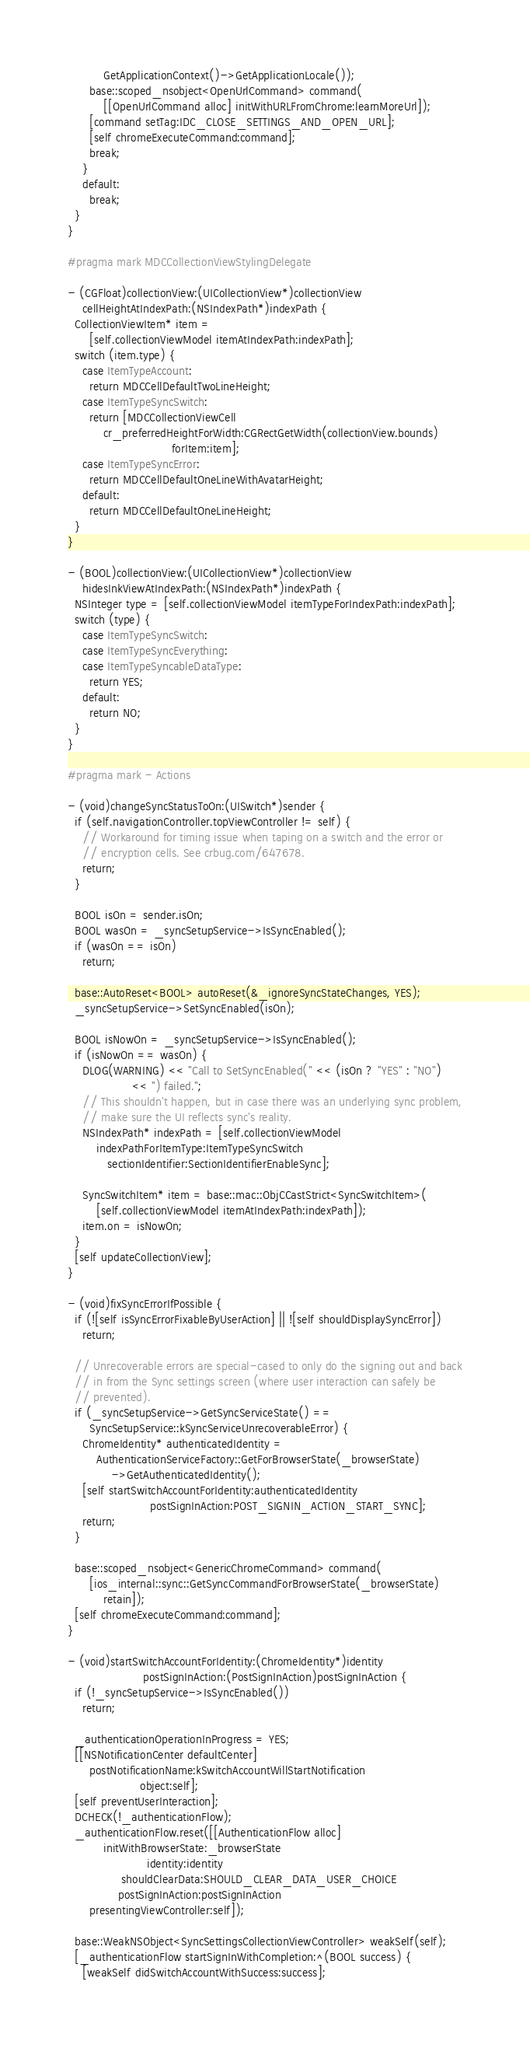Convert code to text. <code><loc_0><loc_0><loc_500><loc_500><_ObjectiveC_>          GetApplicationContext()->GetApplicationLocale());
      base::scoped_nsobject<OpenUrlCommand> command(
          [[OpenUrlCommand alloc] initWithURLFromChrome:learnMoreUrl]);
      [command setTag:IDC_CLOSE_SETTINGS_AND_OPEN_URL];
      [self chromeExecuteCommand:command];
      break;
    }
    default:
      break;
  }
}

#pragma mark MDCCollectionViewStylingDelegate

- (CGFloat)collectionView:(UICollectionView*)collectionView
    cellHeightAtIndexPath:(NSIndexPath*)indexPath {
  CollectionViewItem* item =
      [self.collectionViewModel itemAtIndexPath:indexPath];
  switch (item.type) {
    case ItemTypeAccount:
      return MDCCellDefaultTwoLineHeight;
    case ItemTypeSyncSwitch:
      return [MDCCollectionViewCell
          cr_preferredHeightForWidth:CGRectGetWidth(collectionView.bounds)
                             forItem:item];
    case ItemTypeSyncError:
      return MDCCellDefaultOneLineWithAvatarHeight;
    default:
      return MDCCellDefaultOneLineHeight;
  }
}

- (BOOL)collectionView:(UICollectionView*)collectionView
    hidesInkViewAtIndexPath:(NSIndexPath*)indexPath {
  NSInteger type = [self.collectionViewModel itemTypeForIndexPath:indexPath];
  switch (type) {
    case ItemTypeSyncSwitch:
    case ItemTypeSyncEverything:
    case ItemTypeSyncableDataType:
      return YES;
    default:
      return NO;
  }
}

#pragma mark - Actions

- (void)changeSyncStatusToOn:(UISwitch*)sender {
  if (self.navigationController.topViewController != self) {
    // Workaround for timing issue when taping on a switch and the error or
    // encryption cells. See crbug.com/647678.
    return;
  }

  BOOL isOn = sender.isOn;
  BOOL wasOn = _syncSetupService->IsSyncEnabled();
  if (wasOn == isOn)
    return;

  base::AutoReset<BOOL> autoReset(&_ignoreSyncStateChanges, YES);
  _syncSetupService->SetSyncEnabled(isOn);

  BOOL isNowOn = _syncSetupService->IsSyncEnabled();
  if (isNowOn == wasOn) {
    DLOG(WARNING) << "Call to SetSyncEnabled(" << (isOn ? "YES" : "NO")
                  << ") failed.";
    // This shouldn't happen, but in case there was an underlying sync problem,
    // make sure the UI reflects sync's reality.
    NSIndexPath* indexPath = [self.collectionViewModel
        indexPathForItemType:ItemTypeSyncSwitch
           sectionIdentifier:SectionIdentifierEnableSync];

    SyncSwitchItem* item = base::mac::ObjCCastStrict<SyncSwitchItem>(
        [self.collectionViewModel itemAtIndexPath:indexPath]);
    item.on = isNowOn;
  }
  [self updateCollectionView];
}

- (void)fixSyncErrorIfPossible {
  if (![self isSyncErrorFixableByUserAction] || ![self shouldDisplaySyncError])
    return;

  // Unrecoverable errors are special-cased to only do the signing out and back
  // in from the Sync settings screen (where user interaction can safely be
  // prevented).
  if (_syncSetupService->GetSyncServiceState() ==
      SyncSetupService::kSyncServiceUnrecoverableError) {
    ChromeIdentity* authenticatedIdentity =
        AuthenticationServiceFactory::GetForBrowserState(_browserState)
            ->GetAuthenticatedIdentity();
    [self startSwitchAccountForIdentity:authenticatedIdentity
                       postSignInAction:POST_SIGNIN_ACTION_START_SYNC];
    return;
  }

  base::scoped_nsobject<GenericChromeCommand> command(
      [ios_internal::sync::GetSyncCommandForBrowserState(_browserState)
          retain]);
  [self chromeExecuteCommand:command];
}

- (void)startSwitchAccountForIdentity:(ChromeIdentity*)identity
                     postSignInAction:(PostSignInAction)postSignInAction {
  if (!_syncSetupService->IsSyncEnabled())
    return;

  _authenticationOperationInProgress = YES;
  [[NSNotificationCenter defaultCenter]
      postNotificationName:kSwitchAccountWillStartNotification
                    object:self];
  [self preventUserInteraction];
  DCHECK(!_authenticationFlow);
  _authenticationFlow.reset([[AuthenticationFlow alloc]
          initWithBrowserState:_browserState
                      identity:identity
               shouldClearData:SHOULD_CLEAR_DATA_USER_CHOICE
              postSignInAction:postSignInAction
      presentingViewController:self]);

  base::WeakNSObject<SyncSettingsCollectionViewController> weakSelf(self);
  [_authenticationFlow startSignInWithCompletion:^(BOOL success) {
    [weakSelf didSwitchAccountWithSuccess:success];</code> 